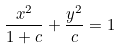Convert formula to latex. <formula><loc_0><loc_0><loc_500><loc_500>\frac { x ^ { 2 } } { 1 + c } + \frac { y ^ { 2 } } { c } = 1</formula> 